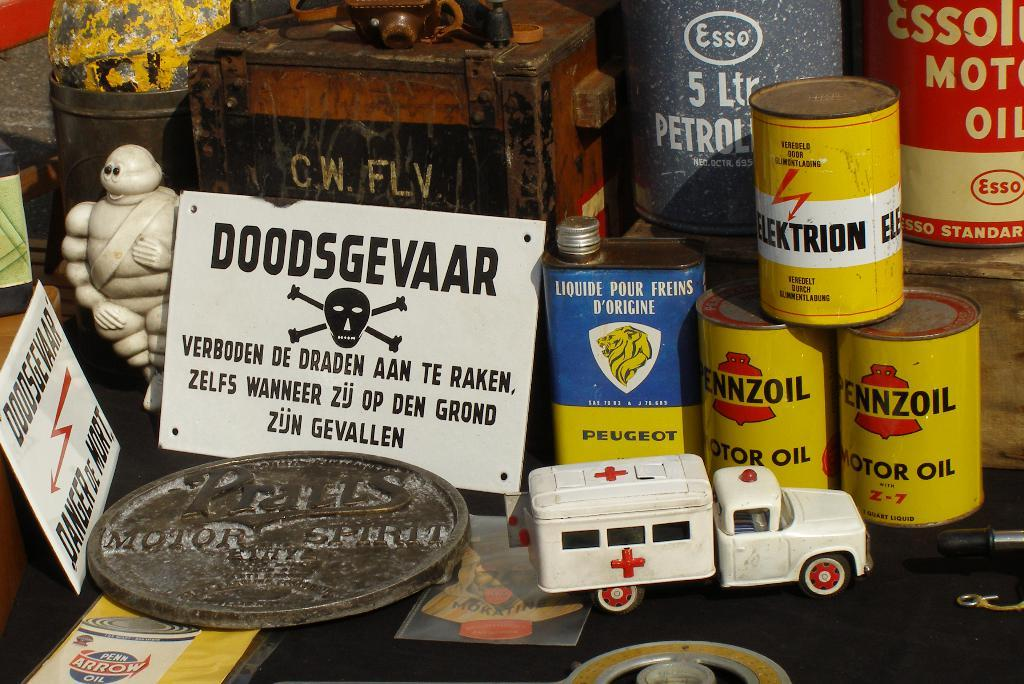Provide a one-sentence caption for the provided image. A collection of old items including some rusted cans of Penzoil oil. 